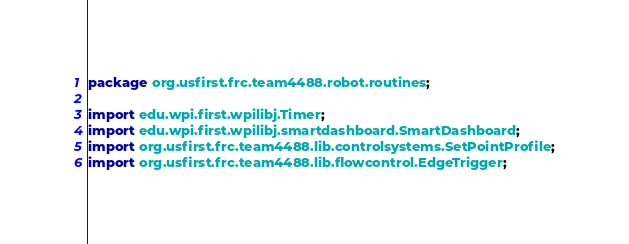Convert code to text. <code><loc_0><loc_0><loc_500><loc_500><_Java_>package org.usfirst.frc.team4488.robot.routines;

import edu.wpi.first.wpilibj.Timer;
import edu.wpi.first.wpilibj.smartdashboard.SmartDashboard;
import org.usfirst.frc.team4488.lib.controlsystems.SetPointProfile;
import org.usfirst.frc.team4488.lib.flowcontrol.EdgeTrigger;</code> 